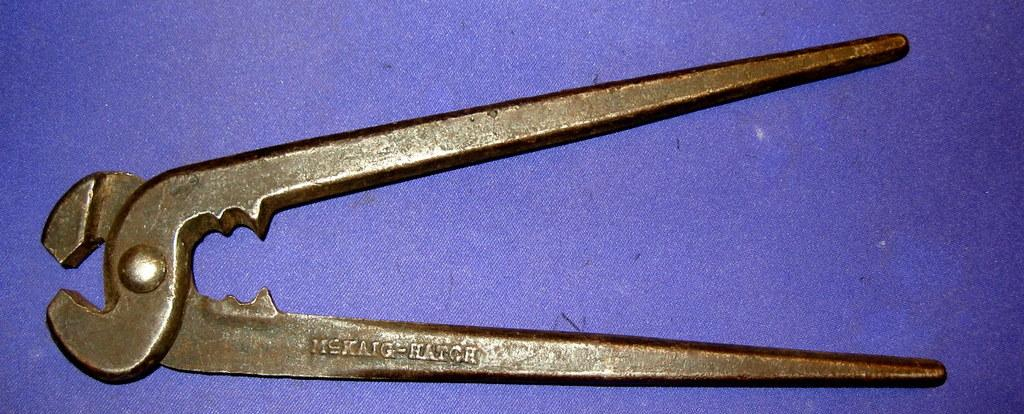What object can be seen in the image? There is a tool in the image. What color or type of surface is the tool placed on? The tool is on a violet surface. How does the tool help with digestion in the image? The tool does not have any direct relation to digestion in the image. 